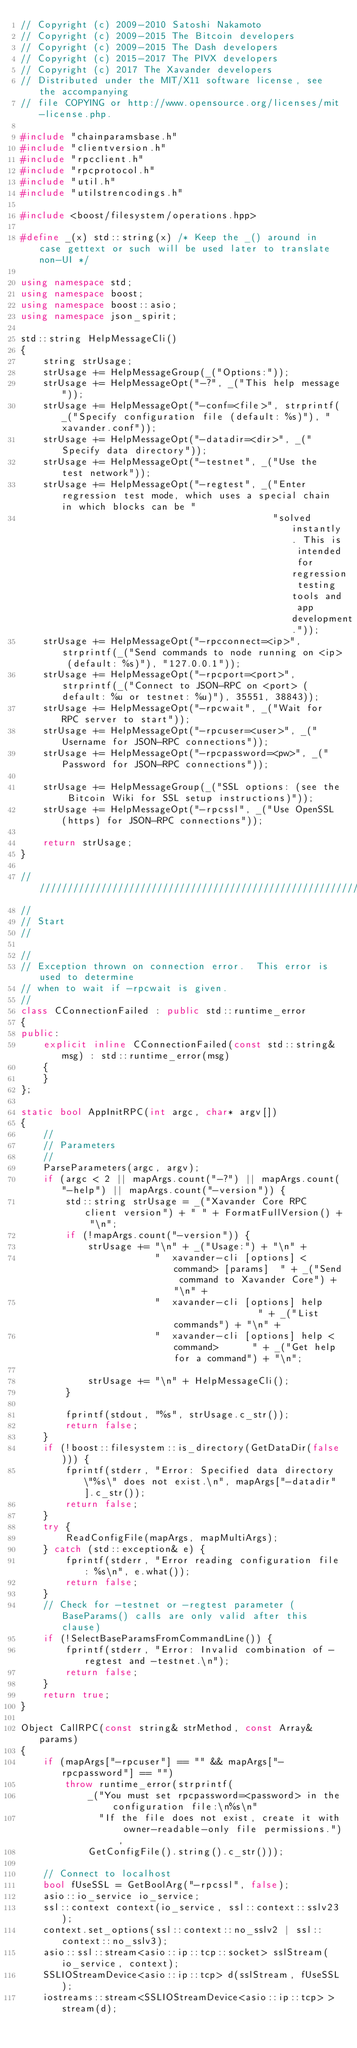Convert code to text. <code><loc_0><loc_0><loc_500><loc_500><_C++_>// Copyright (c) 2009-2010 Satoshi Nakamoto
// Copyright (c) 2009-2015 The Bitcoin developers
// Copyright (c) 2009-2015 The Dash developers
// Copyright (c) 2015-2017 The PIVX developers
// Copyright (c) 2017 The Xavander developers
// Distributed under the MIT/X11 software license, see the accompanying
// file COPYING or http://www.opensource.org/licenses/mit-license.php.

#include "chainparamsbase.h"
#include "clientversion.h"
#include "rpcclient.h"
#include "rpcprotocol.h"
#include "util.h"
#include "utilstrencodings.h"

#include <boost/filesystem/operations.hpp>

#define _(x) std::string(x) /* Keep the _() around in case gettext or such will be used later to translate non-UI */

using namespace std;
using namespace boost;
using namespace boost::asio;
using namespace json_spirit;

std::string HelpMessageCli()
{
    string strUsage;
    strUsage += HelpMessageGroup(_("Options:"));
    strUsage += HelpMessageOpt("-?", _("This help message"));
    strUsage += HelpMessageOpt("-conf=<file>", strprintf(_("Specify configuration file (default: %s)"), "xavander.conf"));
    strUsage += HelpMessageOpt("-datadir=<dir>", _("Specify data directory"));
    strUsage += HelpMessageOpt("-testnet", _("Use the test network"));
    strUsage += HelpMessageOpt("-regtest", _("Enter regression test mode, which uses a special chain in which blocks can be "
                                             "solved instantly. This is intended for regression testing tools and app development."));
    strUsage += HelpMessageOpt("-rpcconnect=<ip>", strprintf(_("Send commands to node running on <ip> (default: %s)"), "127.0.0.1"));
    strUsage += HelpMessageOpt("-rpcport=<port>", strprintf(_("Connect to JSON-RPC on <port> (default: %u or testnet: %u)"), 35551, 38843));
    strUsage += HelpMessageOpt("-rpcwait", _("Wait for RPC server to start"));
    strUsage += HelpMessageOpt("-rpcuser=<user>", _("Username for JSON-RPC connections"));
    strUsage += HelpMessageOpt("-rpcpassword=<pw>", _("Password for JSON-RPC connections"));

    strUsage += HelpMessageGroup(_("SSL options: (see the Bitcoin Wiki for SSL setup instructions)"));
    strUsage += HelpMessageOpt("-rpcssl", _("Use OpenSSL (https) for JSON-RPC connections"));

    return strUsage;
}

//////////////////////////////////////////////////////////////////////////////
//
// Start
//

//
// Exception thrown on connection error.  This error is used to determine
// when to wait if -rpcwait is given.
//
class CConnectionFailed : public std::runtime_error
{
public:
    explicit inline CConnectionFailed(const std::string& msg) : std::runtime_error(msg)
    {
    }
};

static bool AppInitRPC(int argc, char* argv[])
{
    //
    // Parameters
    //
    ParseParameters(argc, argv);
    if (argc < 2 || mapArgs.count("-?") || mapArgs.count("-help") || mapArgs.count("-version")) {
        std::string strUsage = _("Xavander Core RPC client version") + " " + FormatFullVersion() + "\n";
        if (!mapArgs.count("-version")) {
            strUsage += "\n" + _("Usage:") + "\n" +
                        "  xavander-cli [options] <command> [params]  " + _("Send command to Xavander Core") + "\n" +
                        "  xavander-cli [options] help                " + _("List commands") + "\n" +
                        "  xavander-cli [options] help <command>      " + _("Get help for a command") + "\n";

            strUsage += "\n" + HelpMessageCli();
        }

        fprintf(stdout, "%s", strUsage.c_str());
        return false;
    }
    if (!boost::filesystem::is_directory(GetDataDir(false))) {
        fprintf(stderr, "Error: Specified data directory \"%s\" does not exist.\n", mapArgs["-datadir"].c_str());
        return false;
    }
    try {
        ReadConfigFile(mapArgs, mapMultiArgs);
    } catch (std::exception& e) {
        fprintf(stderr, "Error reading configuration file: %s\n", e.what());
        return false;
    }
    // Check for -testnet or -regtest parameter (BaseParams() calls are only valid after this clause)
    if (!SelectBaseParamsFromCommandLine()) {
        fprintf(stderr, "Error: Invalid combination of -regtest and -testnet.\n");
        return false;
    }
    return true;
}

Object CallRPC(const string& strMethod, const Array& params)
{
    if (mapArgs["-rpcuser"] == "" && mapArgs["-rpcpassword"] == "")
        throw runtime_error(strprintf(
            _("You must set rpcpassword=<password> in the configuration file:\n%s\n"
              "If the file does not exist, create it with owner-readable-only file permissions."),
            GetConfigFile().string().c_str()));

    // Connect to localhost
    bool fUseSSL = GetBoolArg("-rpcssl", false);
    asio::io_service io_service;
    ssl::context context(io_service, ssl::context::sslv23);
    context.set_options(ssl::context::no_sslv2 | ssl::context::no_sslv3);
    asio::ssl::stream<asio::ip::tcp::socket> sslStream(io_service, context);
    SSLIOStreamDevice<asio::ip::tcp> d(sslStream, fUseSSL);
    iostreams::stream<SSLIOStreamDevice<asio::ip::tcp> > stream(d);
</code> 